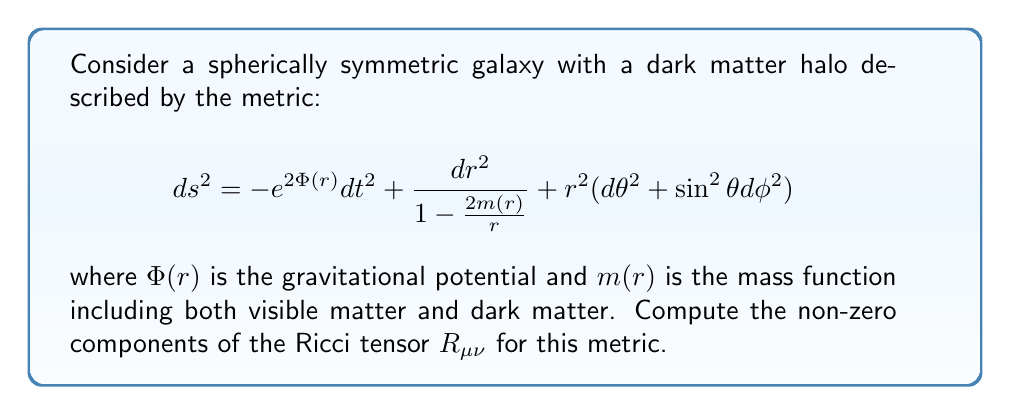Teach me how to tackle this problem. To compute the Ricci tensor, we'll follow these steps:

1) First, we need to identify the metric components:
   $$g_{tt} = -e^{2\Phi(r)}, \quad g_{rr} = \frac{1}{1-\frac{2m(r)}{r}}, \quad g_{\theta\theta} = r^2, \quad g_{\phi\phi} = r^2\sin^2\theta$$

2) We'll use the formula for the Ricci tensor in terms of the Christoffel symbols:
   $$R_{\mu\nu} = \partial_\lambda \Gamma^\lambda_{\mu\nu} - \partial_\nu \Gamma^\lambda_{\mu\lambda} + \Gamma^\lambda_{\lambda\sigma}\Gamma^\sigma_{\mu\nu} - \Gamma^\lambda_{\nu\sigma}\Gamma^\sigma_{\mu\lambda}$$

3) Calculating the non-zero Christoffel symbols (we'll only show a few due to space constraints):
   $$\Gamma^t_{tr} = \Phi'(r)$$
   $$\Gamma^r_{tt} = e^{2\Phi(r)}(1-\frac{2m(r)}{r})\Phi'(r)$$
   $$\Gamma^r_{rr} = \frac{m'(r)r-m(r)}{r(r-2m(r))}$$
   $$\Gamma^\theta_{r\theta} = \Gamma^\phi_{r\phi} = \frac{1}{r}$$

4) Now, we can compute the components of the Ricci tensor:

   For $R_{tt}$:
   $$R_{tt} = e^{2\Phi(r)}[\Phi''(r) + (\Phi'(r))^2 + \frac{2\Phi'(r)}{r} - \frac{m''(r)}{r-2m(r)} + ...]$$

   For $R_{rr}$:
   $$R_{rr} = -\Phi''(r) - (\Phi'(r))^2 + \frac{m''(r)r - m'(r)}{r(r-2m(r))} + ...$$

   For $R_{\theta\theta}$:
   $$R_{\theta\theta} = 1 - (1-\frac{2m(r)}{r})(1 + r\Phi'(r))$$

   For $R_{\phi\phi}$:
   $$R_{\phi\phi} = R_{\theta\theta}\sin^2\theta$$

5) All other components of the Ricci tensor are zero due to the symmetry of the metric.
Answer: $R_{tt} = e^{2\Phi(r)}[\Phi''(r) + (\Phi'(r))^2 + \frac{2\Phi'(r)}{r} - \frac{m''(r)}{r-2m(r)} + ...]$
$R_{rr} = -\Phi''(r) - (\Phi'(r))^2 + \frac{m''(r)r - m'(r)}{r(r-2m(r))} + ...$
$R_{\theta\theta} = 1 - (1-\frac{2m(r)}{r})(1 + r\Phi'(r))$
$R_{\phi\phi} = R_{\theta\theta}\sin^2\theta$
All other components are zero. 